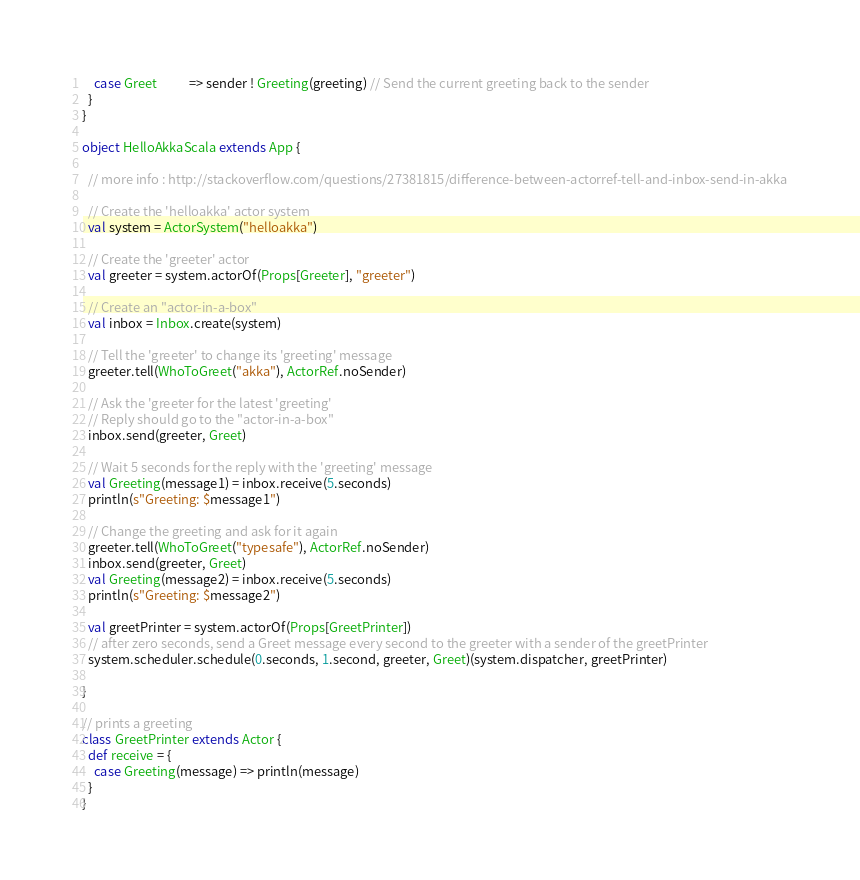<code> <loc_0><loc_0><loc_500><loc_500><_Scala_>    case Greet           => sender ! Greeting(greeting) // Send the current greeting back to the sender
  }
}

object HelloAkkaScala extends App {

  // more info : http://stackoverflow.com/questions/27381815/difference-between-actorref-tell-and-inbox-send-in-akka

  // Create the 'helloakka' actor system
  val system = ActorSystem("helloakka")

  // Create the 'greeter' actor
  val greeter = system.actorOf(Props[Greeter], "greeter")

  // Create an "actor-in-a-box"
  val inbox = Inbox.create(system)

  // Tell the 'greeter' to change its 'greeting' message
  greeter.tell(WhoToGreet("akka"), ActorRef.noSender)

  // Ask the 'greeter for the latest 'greeting'
  // Reply should go to the "actor-in-a-box"
  inbox.send(greeter, Greet)

  // Wait 5 seconds for the reply with the 'greeting' message
  val Greeting(message1) = inbox.receive(5.seconds)
  println(s"Greeting: $message1")

  // Change the greeting and ask for it again
  greeter.tell(WhoToGreet("typesafe"), ActorRef.noSender)
  inbox.send(greeter, Greet)
  val Greeting(message2) = inbox.receive(5.seconds)
  println(s"Greeting: $message2")

  val greetPrinter = system.actorOf(Props[GreetPrinter])
  // after zero seconds, send a Greet message every second to the greeter with a sender of the greetPrinter
  system.scheduler.schedule(0.seconds, 1.second, greeter, Greet)(system.dispatcher, greetPrinter)
  
}

// prints a greeting
class GreetPrinter extends Actor {
  def receive = {
    case Greeting(message) => println(message)
  }
}</code> 